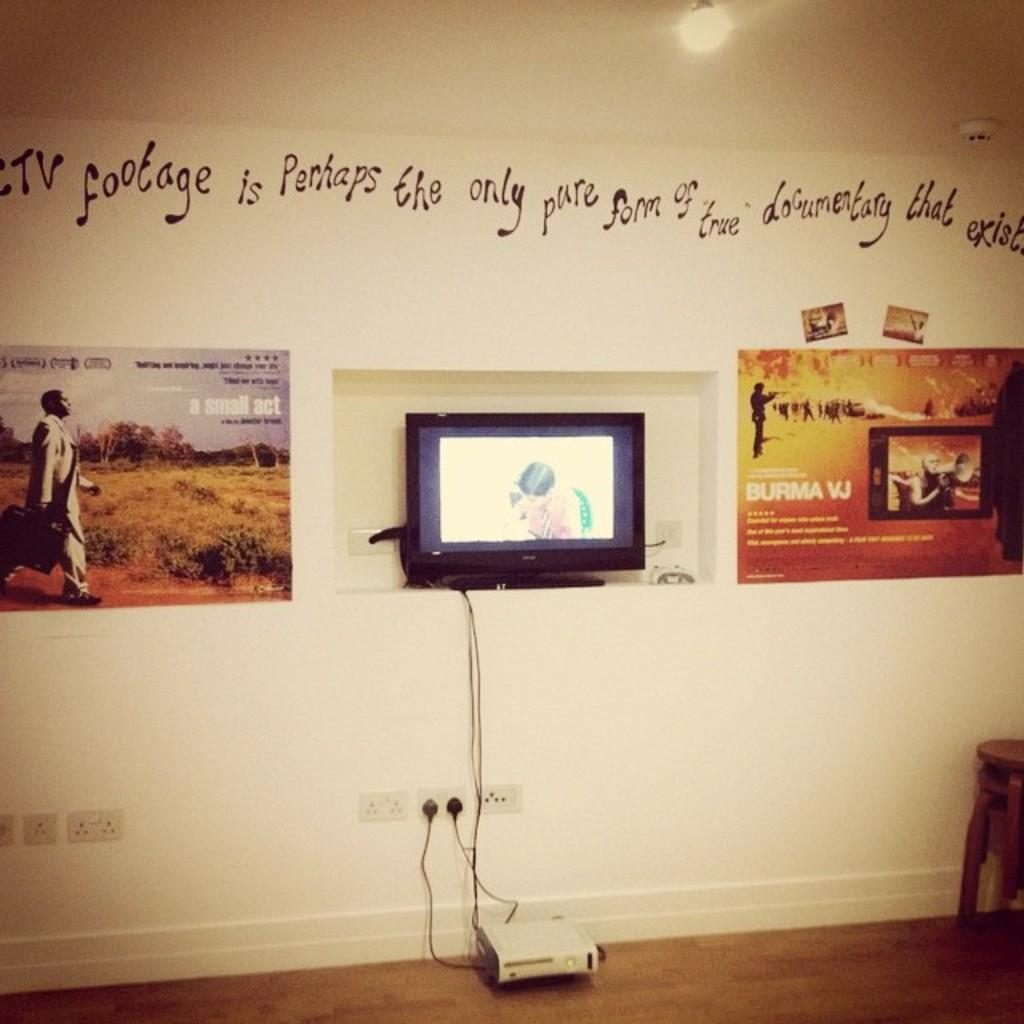<image>
Summarize the visual content of the image. Above a display screen, curly writing boasts about using footage as documentary. 